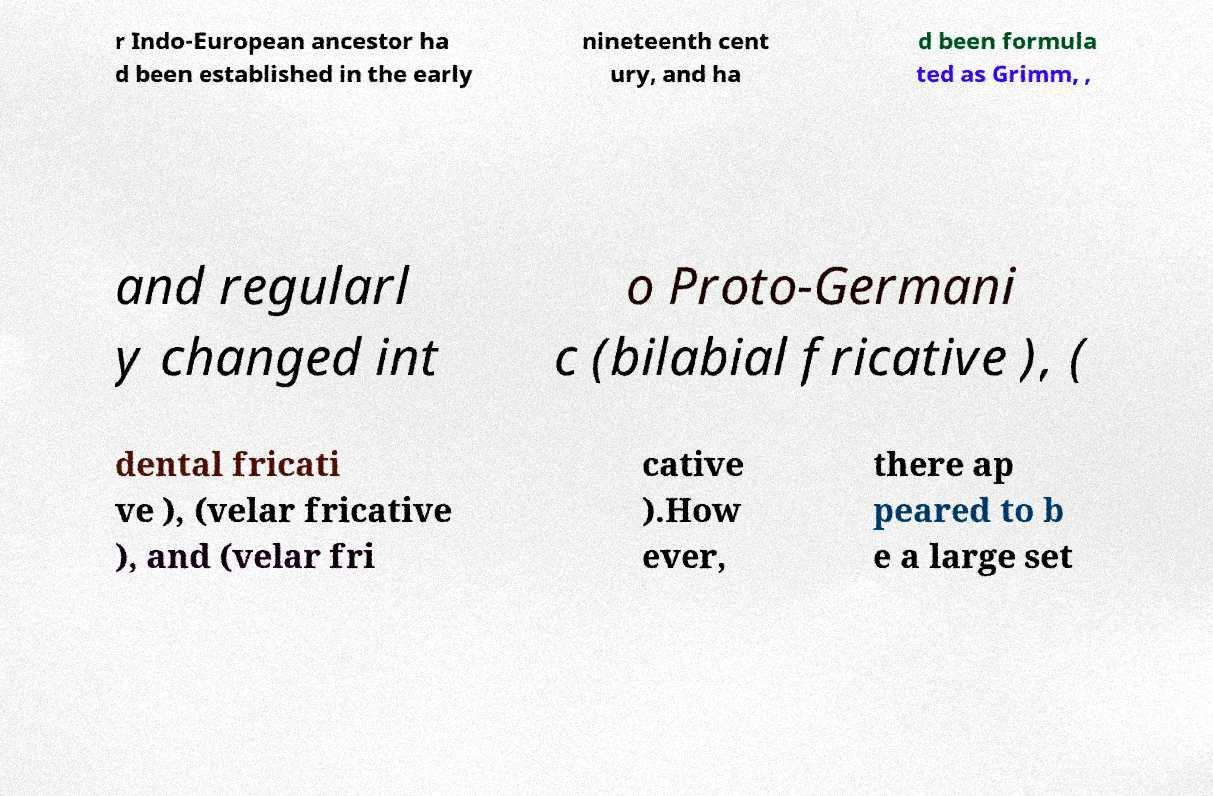For documentation purposes, I need the text within this image transcribed. Could you provide that? r Indo-European ancestor ha d been established in the early nineteenth cent ury, and ha d been formula ted as Grimm, , and regularl y changed int o Proto-Germani c (bilabial fricative ), ( dental fricati ve ), (velar fricative ), and (velar fri cative ).How ever, there ap peared to b e a large set 